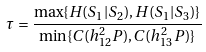<formula> <loc_0><loc_0><loc_500><loc_500>\tau = \frac { \max \{ H ( S _ { 1 } | S _ { 2 } ) , H ( S _ { 1 } | S _ { 3 } ) \} } { \min \{ C ( h _ { 1 2 } ^ { 2 } P ) , C ( h _ { 1 3 } ^ { 2 } P ) \} }</formula> 